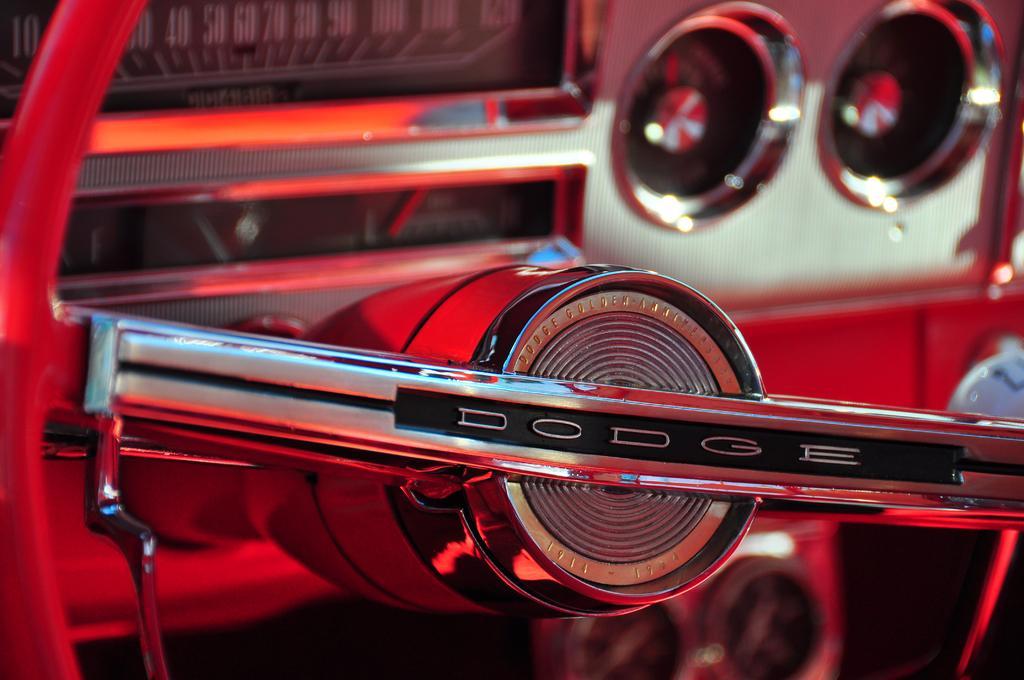Describe this image in one or two sentences. In this image we can see the inner view of a motor vehicle. 